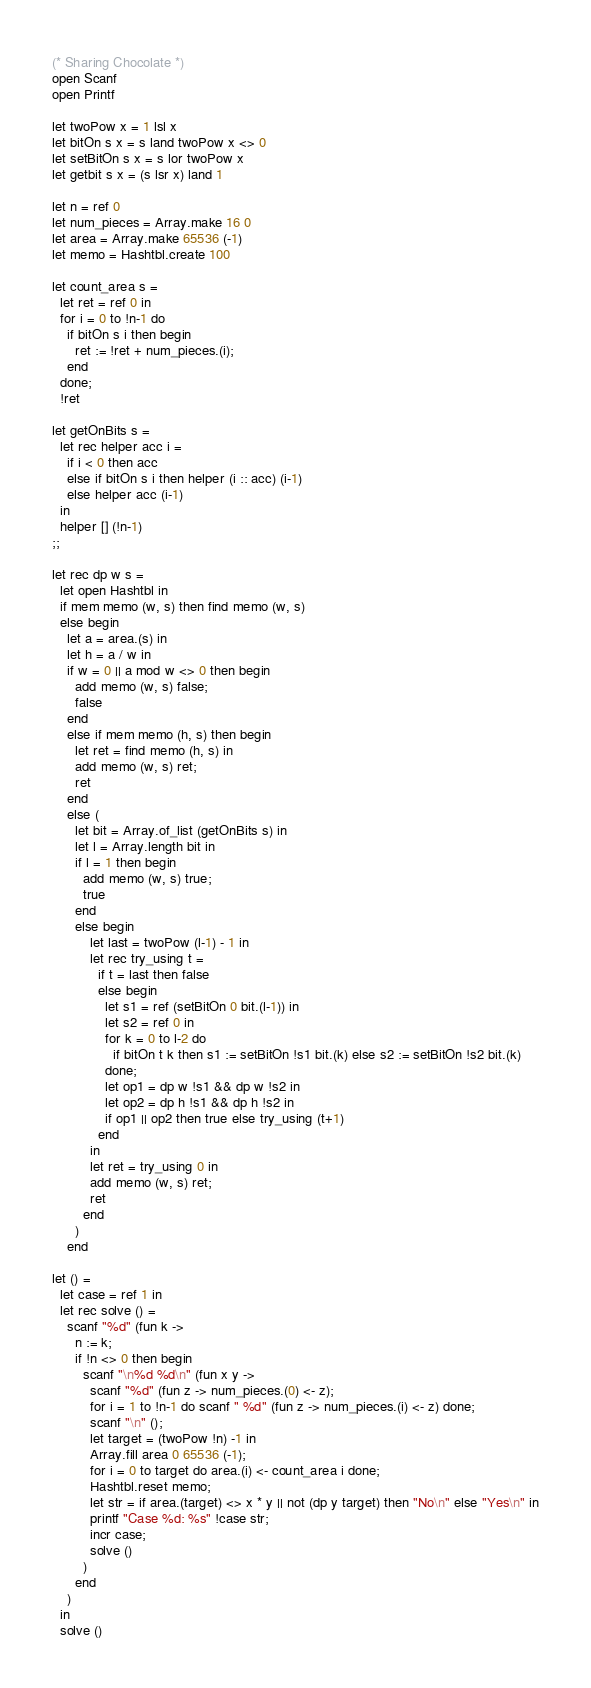Convert code to text. <code><loc_0><loc_0><loc_500><loc_500><_OCaml_>(* Sharing Chocolate *)
open Scanf
open Printf

let twoPow x = 1 lsl x
let bitOn s x = s land twoPow x <> 0
let setBitOn s x = s lor twoPow x
let getbit s x = (s lsr x) land 1

let n = ref 0
let num_pieces = Array.make 16 0
let area = Array.make 65536 (-1)
let memo = Hashtbl.create 100

let count_area s =
  let ret = ref 0 in
  for i = 0 to !n-1 do
    if bitOn s i then begin
      ret := !ret + num_pieces.(i);
    end
  done;
  !ret

let getOnBits s =
  let rec helper acc i =
    if i < 0 then acc
    else if bitOn s i then helper (i :: acc) (i-1)
    else helper acc (i-1)
  in
  helper [] (!n-1)
;;

let rec dp w s =
  let open Hashtbl in
  if mem memo (w, s) then find memo (w, s)
  else begin
    let a = area.(s) in
    let h = a / w in
    if w = 0 || a mod w <> 0 then begin
      add memo (w, s) false;
      false
    end
    else if mem memo (h, s) then begin
      let ret = find memo (h, s) in
      add memo (w, s) ret;
      ret
    end
    else (
      let bit = Array.of_list (getOnBits s) in
      let l = Array.length bit in
      if l = 1 then begin
        add memo (w, s) true;
        true
      end
      else begin
          let last = twoPow (l-1) - 1 in
          let rec try_using t =
            if t = last then false
            else begin
              let s1 = ref (setBitOn 0 bit.(l-1)) in
              let s2 = ref 0 in
              for k = 0 to l-2 do 
                if bitOn t k then s1 := setBitOn !s1 bit.(k) else s2 := setBitOn !s2 bit.(k)
              done;
              let op1 = dp w !s1 && dp w !s2 in
              let op2 = dp h !s1 && dp h !s2 in
              if op1 || op2 then true else try_using (t+1)
            end
          in
          let ret = try_using 0 in
          add memo (w, s) ret;
          ret
        end
      )
    end

let () =
  let case = ref 1 in
  let rec solve () =
    scanf "%d" (fun k ->
      n := k;
      if !n <> 0 then begin
        scanf "\n%d %d\n" (fun x y ->
          scanf "%d" (fun z -> num_pieces.(0) <- z);
          for i = 1 to !n-1 do scanf " %d" (fun z -> num_pieces.(i) <- z) done;
          scanf "\n" ();
          let target = (twoPow !n) -1 in
          Array.fill area 0 65536 (-1);
          for i = 0 to target do area.(i) <- count_area i done;
          Hashtbl.reset memo;
          let str = if area.(target) <> x * y || not (dp y target) then "No\n" else "Yes\n" in
          printf "Case %d: %s" !case str;
          incr case;
          solve ()
        )
      end
    )
  in 
  solve ()


</code> 